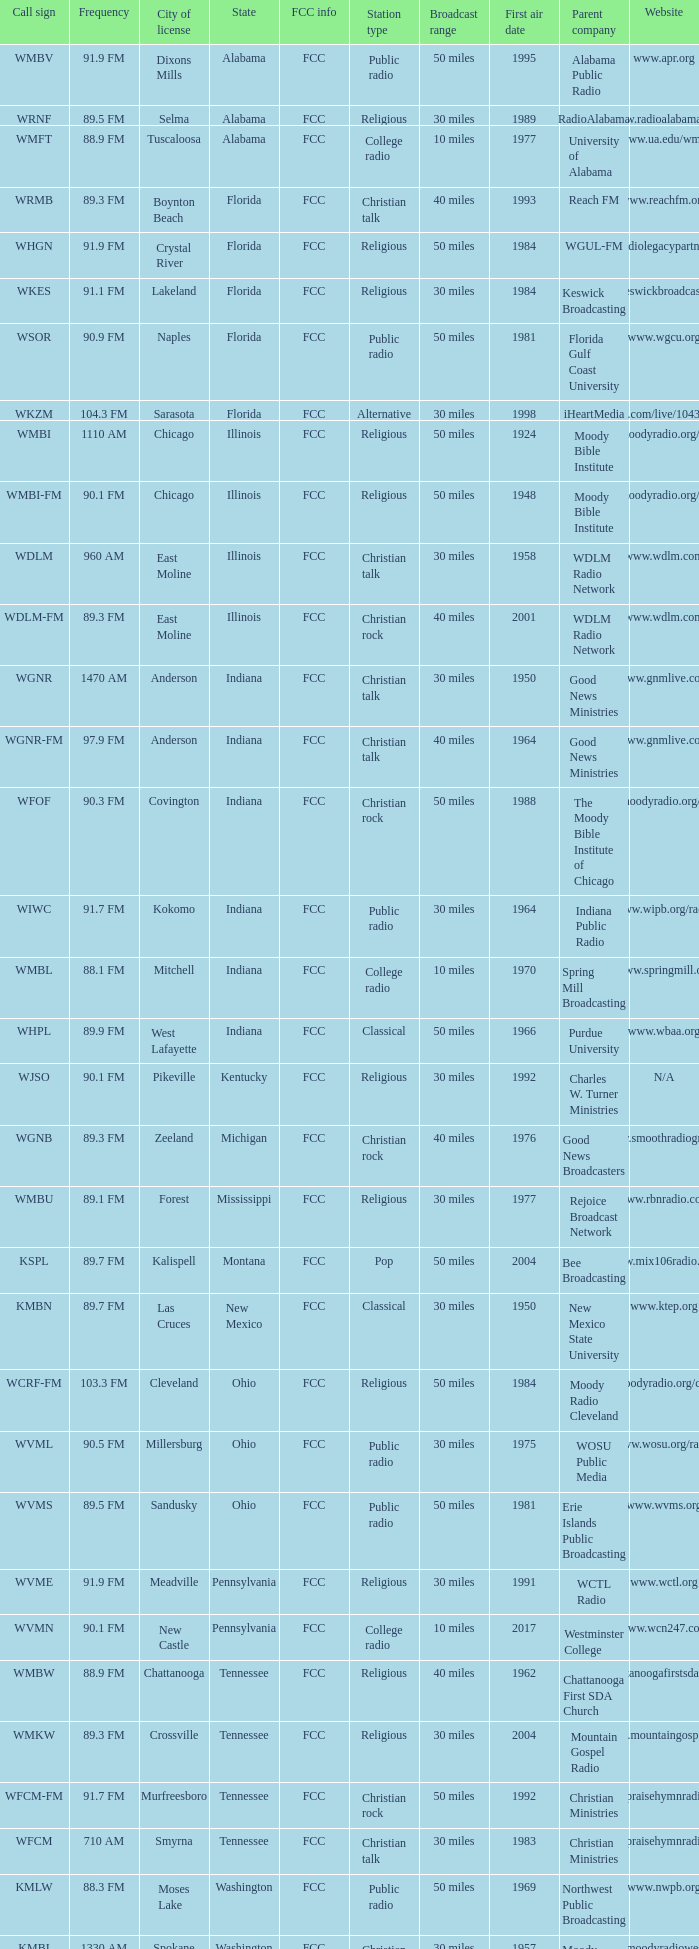Can you provide the frequency for the wgnr-fm radio station? 97.9 FM. 